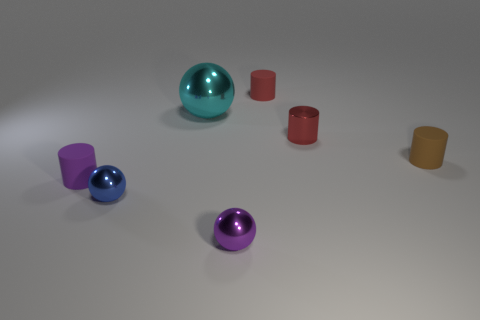Is there anything else that is the same size as the cyan metal thing?
Give a very brief answer. No. There is a small metal object that is left of the small purple metallic thing; what shape is it?
Give a very brief answer. Sphere. Is the shape of the red metallic thing the same as the tiny purple metal object?
Your answer should be very brief. No. Is the number of purple spheres right of the large cyan sphere the same as the number of green cubes?
Make the answer very short. No. What shape is the brown rubber thing?
Provide a succinct answer. Cylinder. Is there any other thing that is the same color as the big thing?
Provide a succinct answer. No. There is a cylinder in front of the brown thing; does it have the same size as the matte cylinder that is behind the brown matte thing?
Provide a succinct answer. Yes. The tiny brown object that is behind the ball that is left of the big cyan ball is what shape?
Give a very brief answer. Cylinder. Is the size of the blue metallic ball the same as the shiny object that is behind the tiny red metal object?
Make the answer very short. No. What size is the cyan metallic sphere behind the tiny purple thing in front of the object that is on the left side of the tiny blue object?
Keep it short and to the point. Large. 